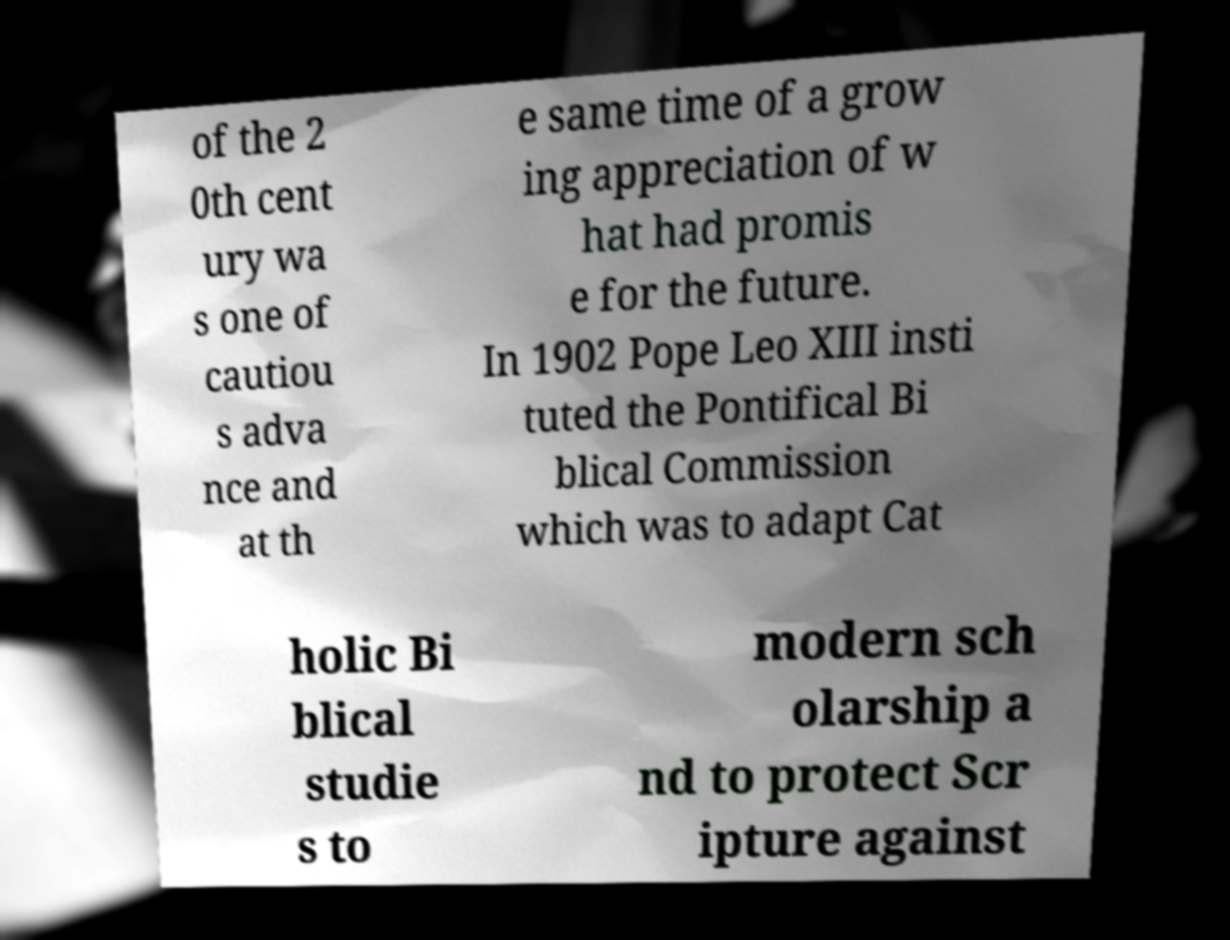Can you accurately transcribe the text from the provided image for me? of the 2 0th cent ury wa s one of cautiou s adva nce and at th e same time of a grow ing appreciation of w hat had promis e for the future. In 1902 Pope Leo XIII insti tuted the Pontifical Bi blical Commission which was to adapt Cat holic Bi blical studie s to modern sch olarship a nd to protect Scr ipture against 